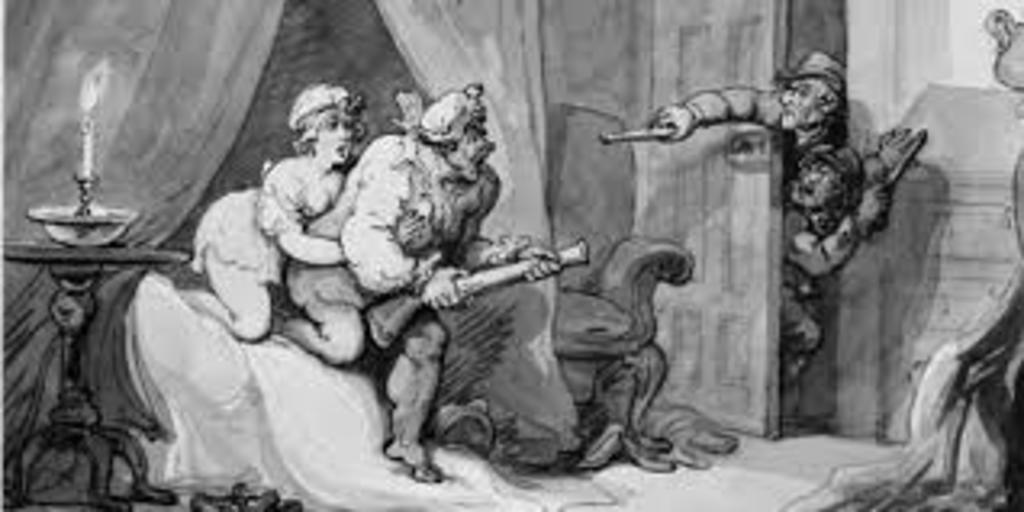What type of image is present in the picture? There is an animated printed image in the picture. What type of test can be seen being conducted on the stone in the image? There is no stone or test present in the image; it features an animated printed image. What is the texture of the chin in the image? There is no chin present in the image, as it features an animated printed image. 